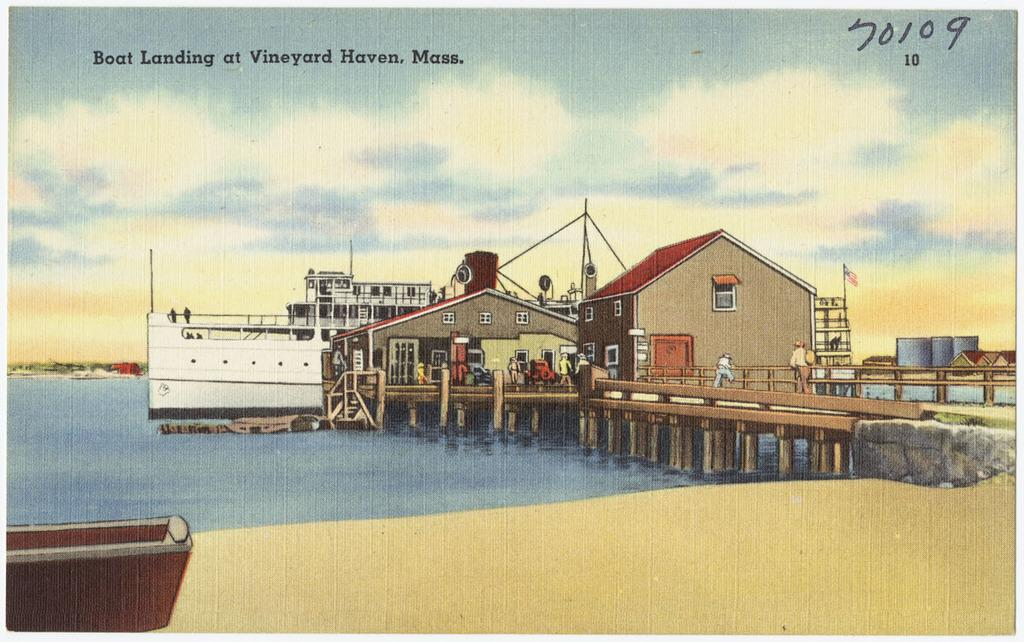What is the main subject of the image? There is a painting in the image. What scene is depicted in the painting? The painting depicts a boat landing at Vineyard Haven. Are there any people in the painting? Yes, there are a few people standing in the painting. How is the distribution of the calendar managed in the painting? There is no calendar present in the painting, so the distribution cannot be managed. 